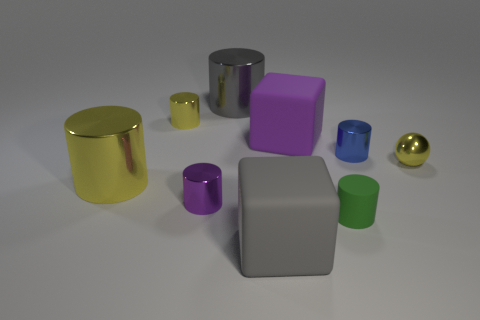Are there any other metal spheres that have the same color as the ball?
Provide a succinct answer. No. Are there fewer big green rubber cylinders than small matte cylinders?
Provide a short and direct response. Yes. What number of objects are yellow metallic cylinders or shiny cylinders to the right of the green matte cylinder?
Provide a short and direct response. 3. Are there any tiny green cylinders made of the same material as the small purple cylinder?
Offer a terse response. No. What material is the yellow object that is the same size as the gray cylinder?
Offer a terse response. Metal. There is a cube that is behind the gray thing that is in front of the tiny yellow shiny sphere; what is it made of?
Provide a succinct answer. Rubber. Does the large rubber object that is behind the gray matte block have the same shape as the tiny purple metallic thing?
Offer a terse response. No. There is another large cylinder that is the same material as the big gray cylinder; what is its color?
Provide a succinct answer. Yellow. What is the block left of the big purple rubber thing made of?
Offer a very short reply. Rubber. Is the shape of the tiny blue thing the same as the tiny yellow thing to the left of the purple metal cylinder?
Keep it short and to the point. Yes. 